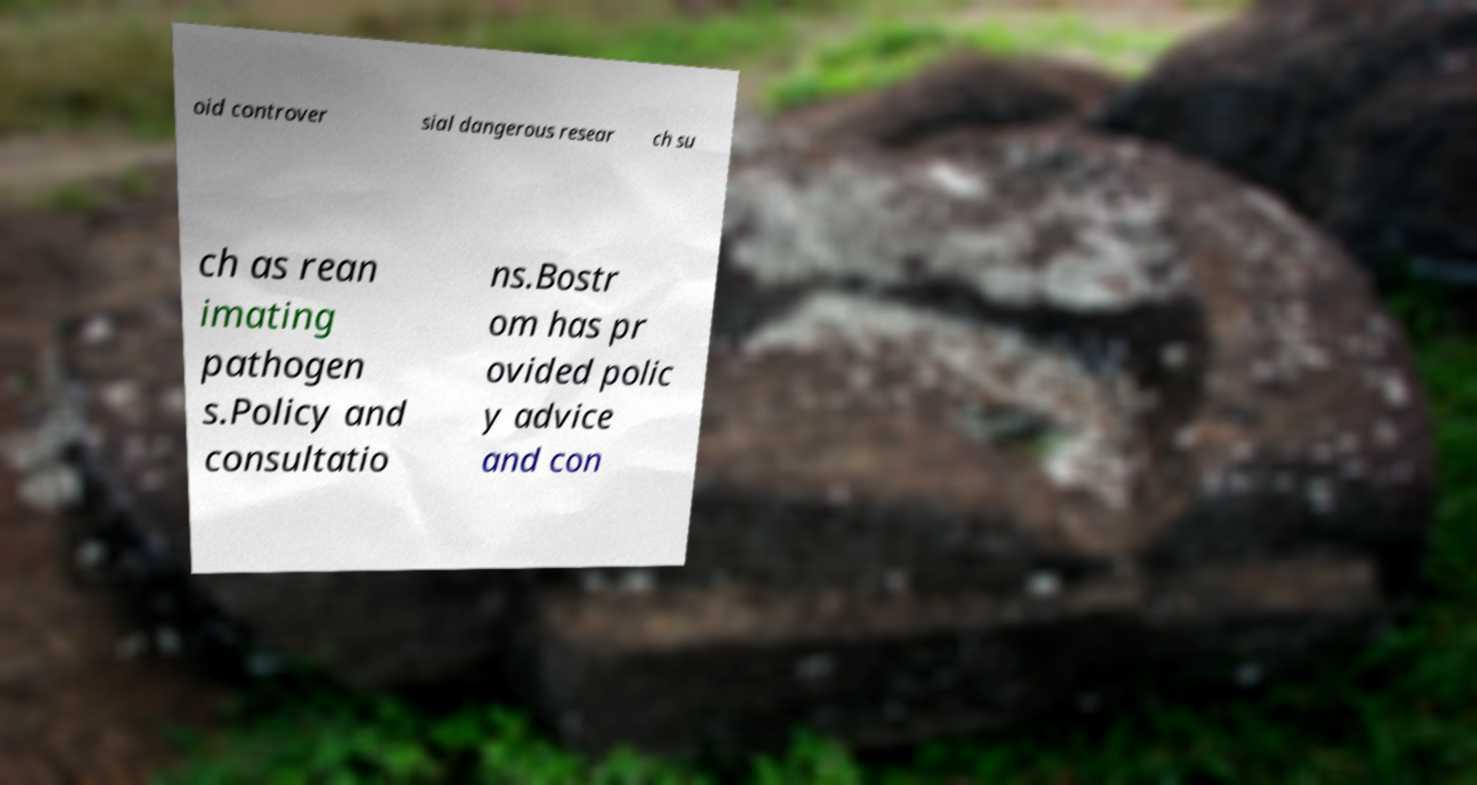What messages or text are displayed in this image? I need them in a readable, typed format. oid controver sial dangerous resear ch su ch as rean imating pathogen s.Policy and consultatio ns.Bostr om has pr ovided polic y advice and con 